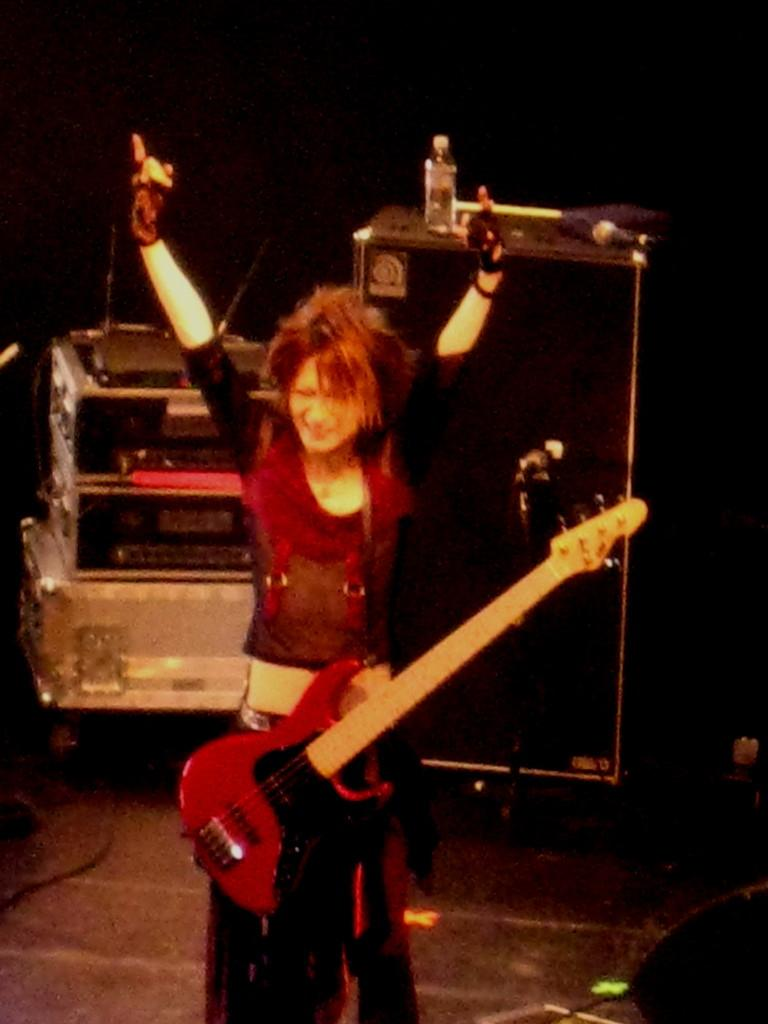Who is the main subject in the image? There is a woman in the image. What is the woman doing in the image? The woman is standing in the image. What is the woman holding in the image? The woman is carrying a guitar in the image. What can be seen in the background of the image? There is a water bottle and a speaker in the background of the image. How many girls are carrying parcels in the image? There are no girls or parcels present in the image; it features a woman carrying a guitar. What type of earthquake can be seen in the image? There is no earthquake present in the image. 